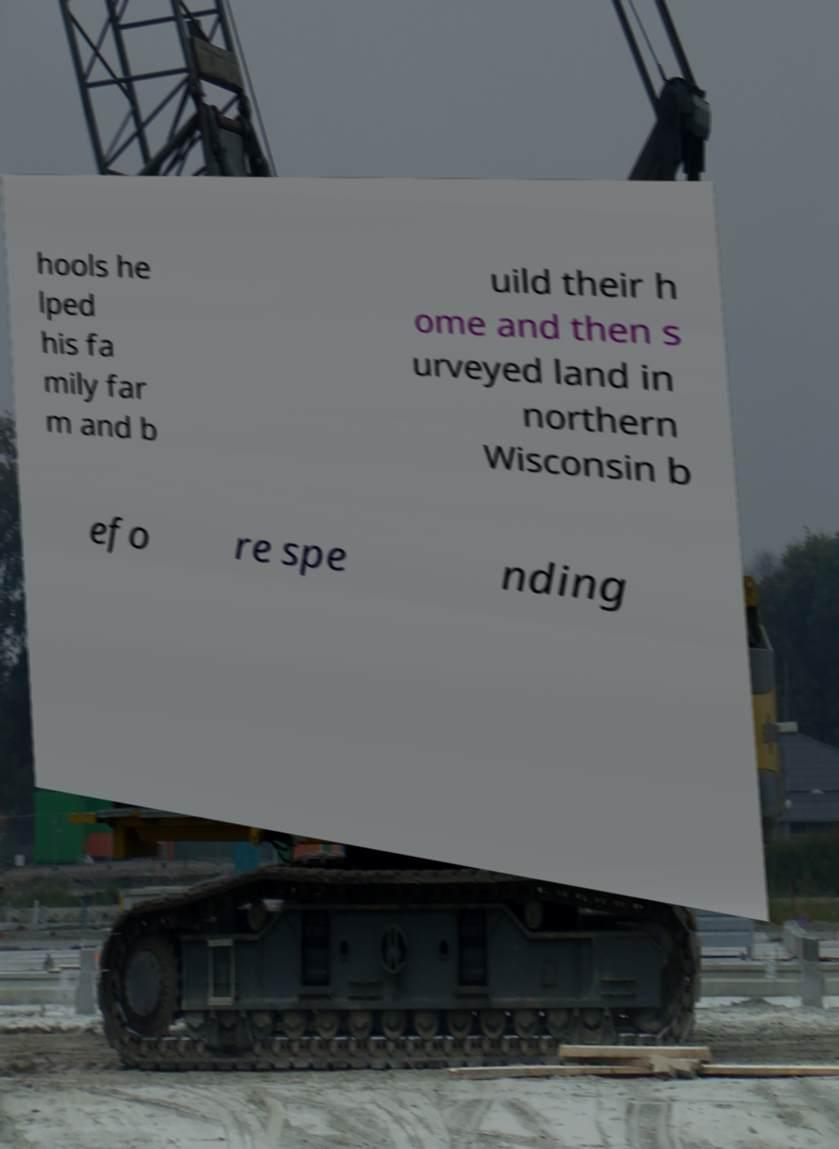Could you extract and type out the text from this image? hools he lped his fa mily far m and b uild their h ome and then s urveyed land in northern Wisconsin b efo re spe nding 